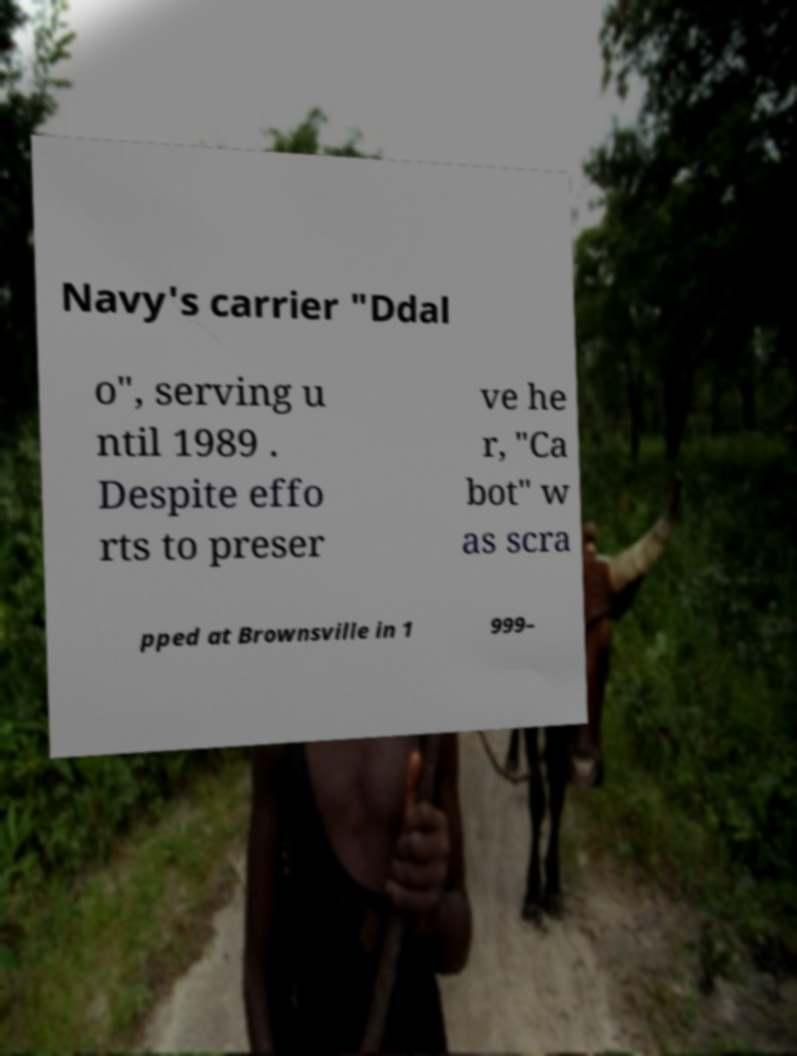What messages or text are displayed in this image? I need them in a readable, typed format. Navy's carrier "Ddal o", serving u ntil 1989 . Despite effo rts to preser ve he r, "Ca bot" w as scra pped at Brownsville in 1 999– 